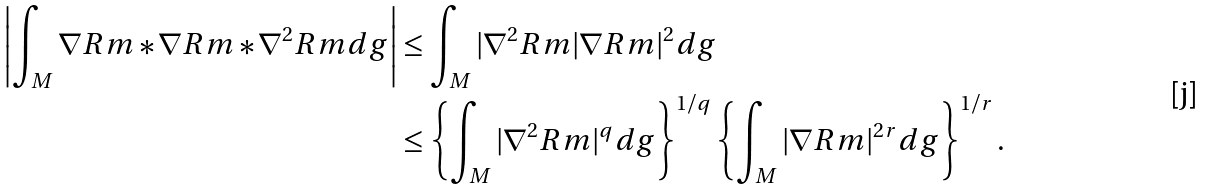<formula> <loc_0><loc_0><loc_500><loc_500>\left | \int _ { M } \nabla R m * \nabla R m * \nabla ^ { 2 } R m d g \right | & \leq \int _ { M } | \nabla ^ { 2 } R m | \nabla R m | ^ { 2 } d g \\ & \leq \left \{ \int _ { M } | \nabla ^ { 2 } R m | ^ { q } d g \right \} ^ { 1 / q } \left \{ \int _ { M } | \nabla R m | ^ { 2 r } d g \right \} ^ { 1 / r } .</formula> 